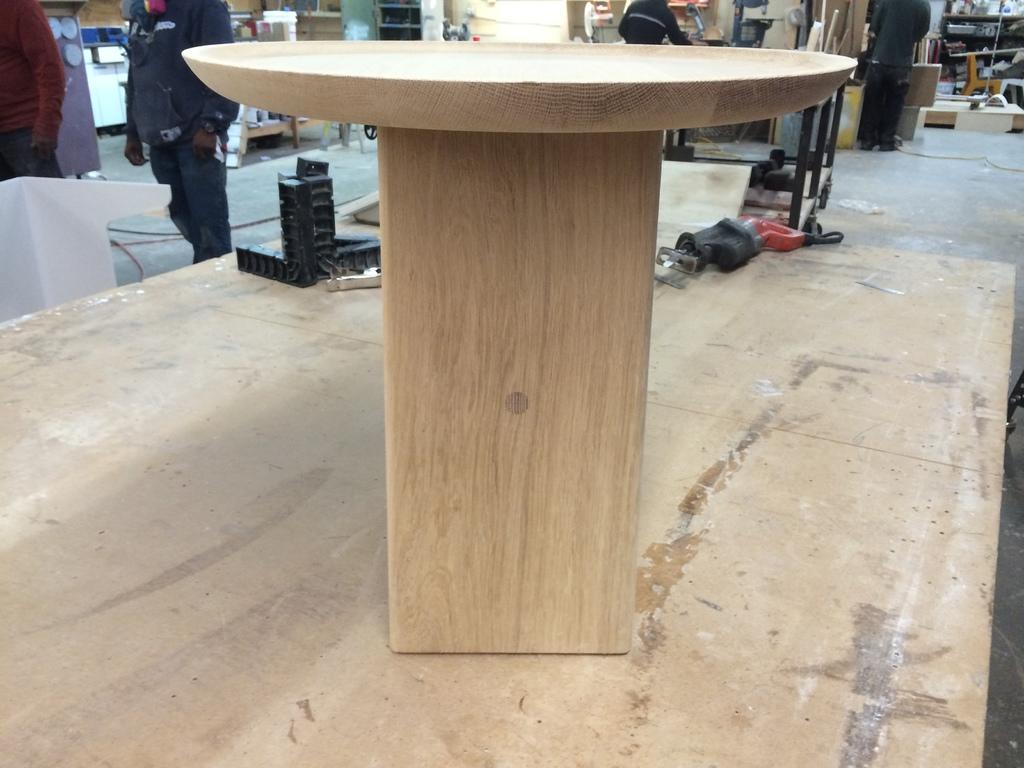What is the wooden object on the table in the image? The wooden object on the table is not specified in the facts provided. What type of machinery items can be seen in the image? There are machinery items in the image, but their specific types are not mentioned in the facts. What can be observed in the background of the image? In the background of the image, there are persons standing and wooden planks. What type of record is being played in the background of the image? There is no record being played in the background of the image, as the facts provided do not mention any audio or music-related elements. Is there a battle taking place in the image? There is no battle depicted in the image, as the facts provided do not mention any conflict or fighting. 